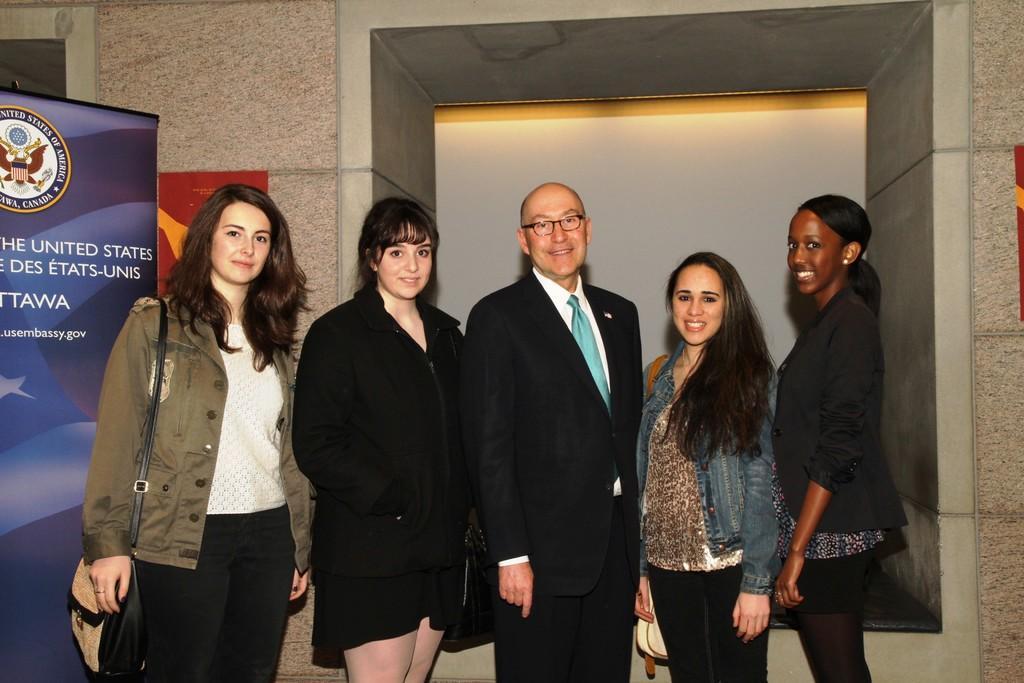Could you give a brief overview of what you see in this image? In the middle of the image few people are standing and smiling. Behind them there is banner and wall. 